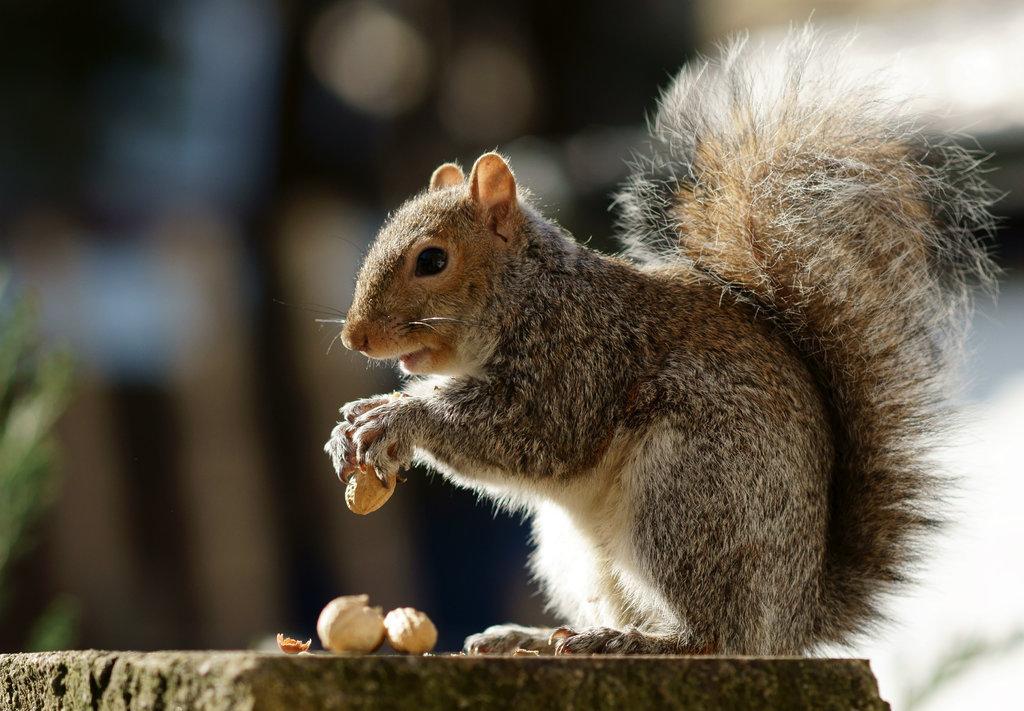Describe this image in one or two sentences. In this image we can see a squirrel holding an object and standing on a surface. In front of the squirrel there are few objects and behind it the background is blurred. 